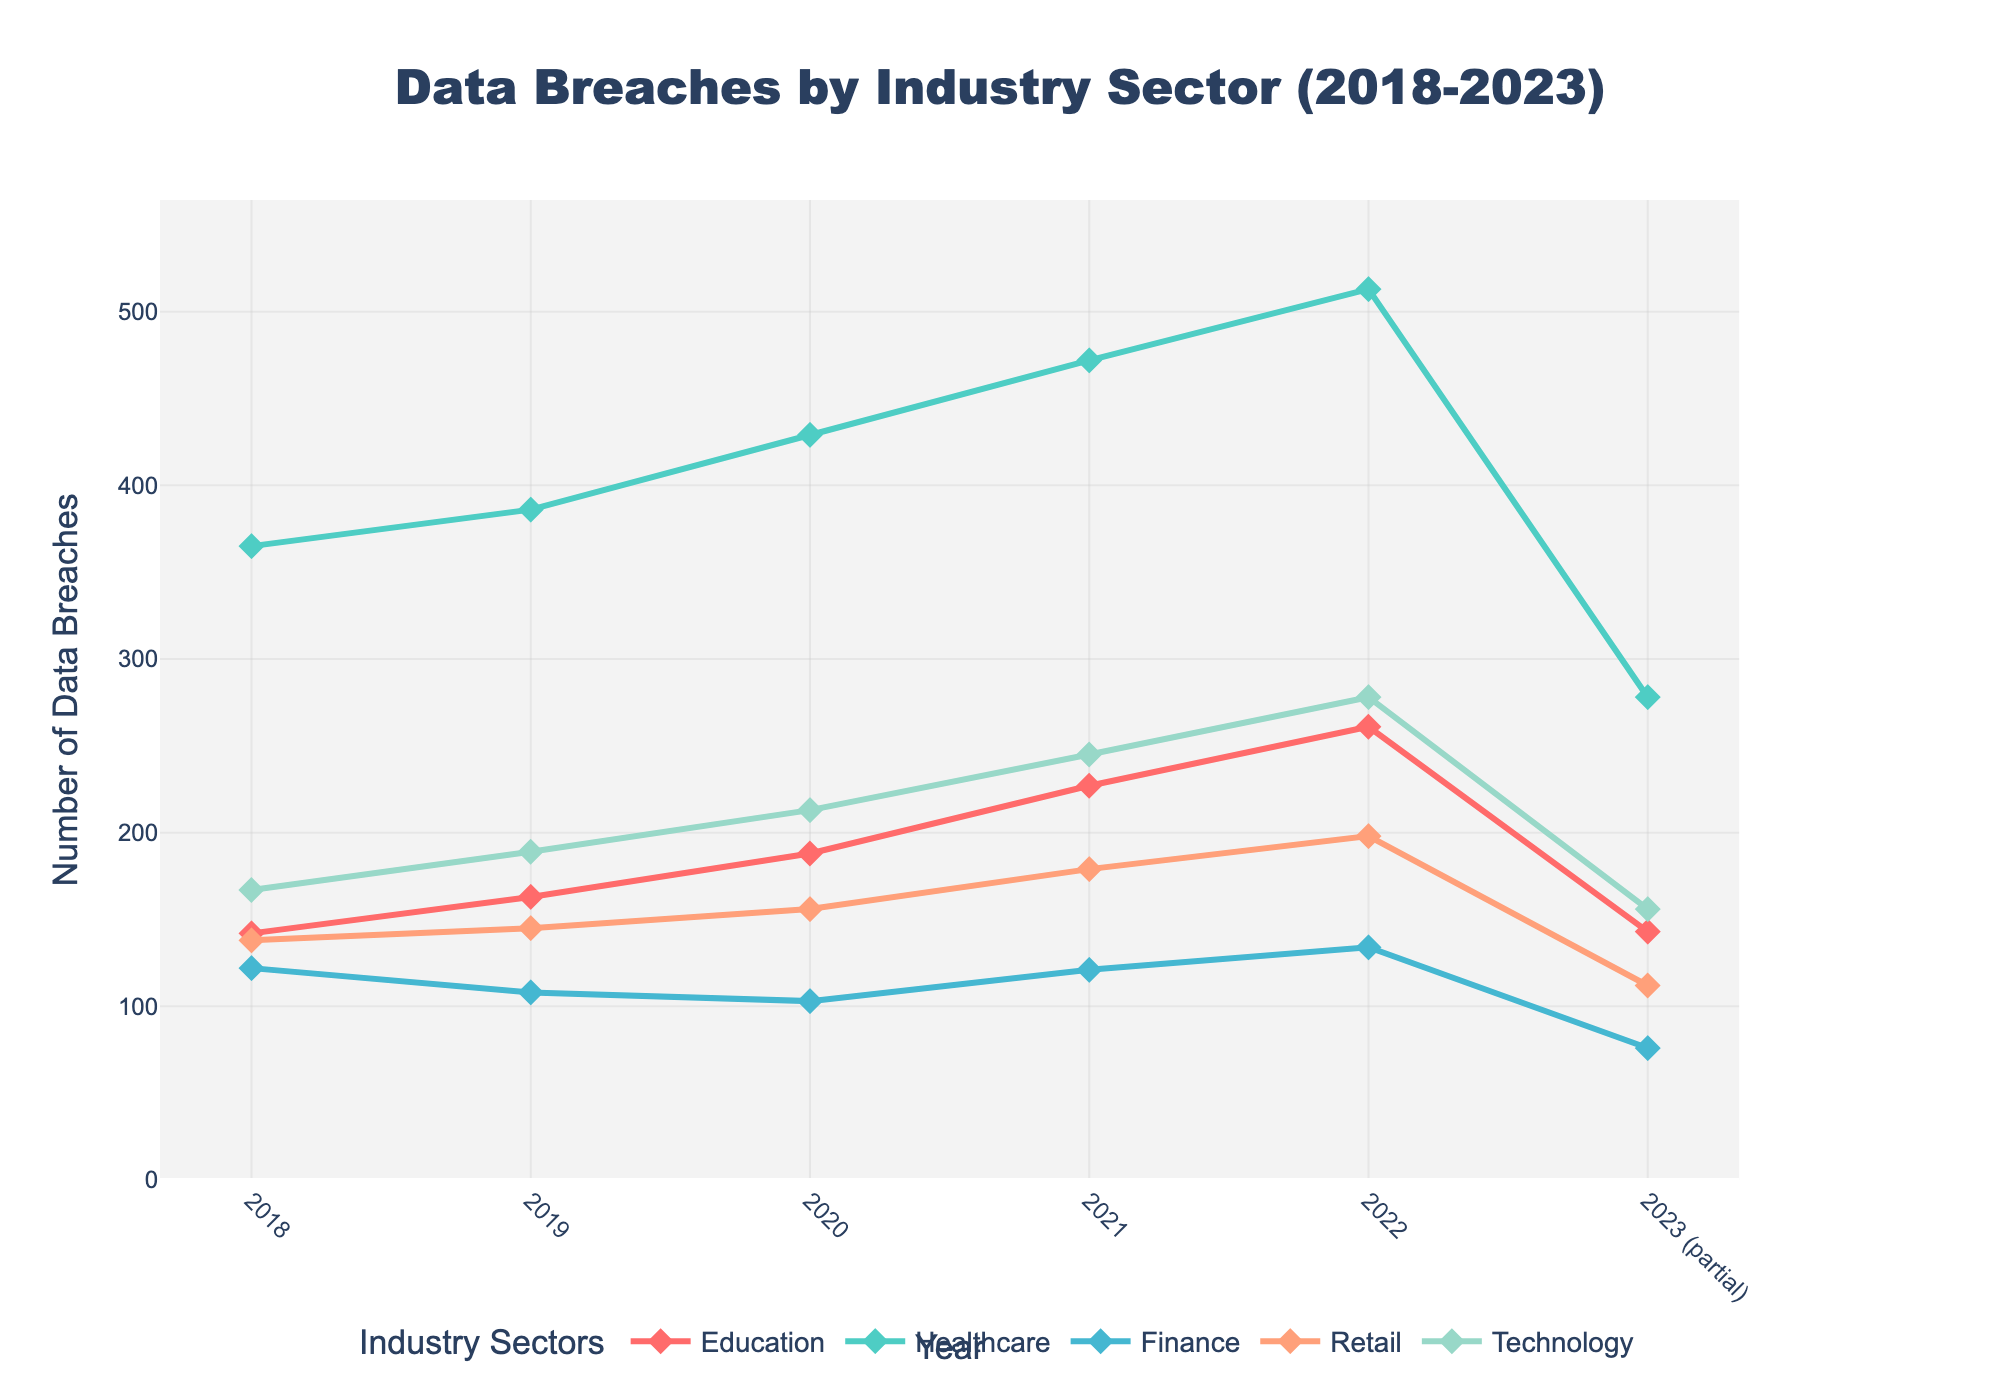Which year experienced the highest number of data breaches in educational institutions? Looking at the line for educational institutions, we identify the peak point. The highest value on this line appears in 2022 with 261 breaches.
Answer: 2022 How does the number of data breaches in educational institutions in 2020 compare to that in the finance sector for the same year? For 2020, the number of data breaches in educational institutions is 188, whereas the finance sector experienced 103 breaches. Therefore, educational institutions had 85 more breaches than the finance sector.
Answer: 85 more Between 2018 and 2022, which year saw the largest increase in data breaches for educational institutions? By examining the difference between each consecutive year's data breaches for educational institutions, we find that the largest increase occurred from 2021 (227 breaches) to 2022 (261 breaches), a difference of 34.
Answer: From 2021 to 2022 What is the overall trend in the number of data breaches in educational institutions over the years shown? The trend line for educational institutions shows a consistent increase from 142 breaches in 2018 to 261 in 2022, indicating a rising trend.
Answer: Increasing Compared to 2021, did the year 2022 see more or fewer data breaches in the healthcare sector? By how many? In 2021, the healthcare sector had 472 breaches, and in 2022 it had 513. Comparing these numbers shows that there were 41 more breaches in 2022.
Answer: 41 more What is the average number of data breaches in educational institutions from 2018 to 2022? First, sum the numbers for each year (142 + 163 + 188 + 227 + 261 = 981). Then, divide by the number of years (5) to get the average: 981 / 5 = 196.2.
Answer: 196.2 By how much did the number of data breaches in educational institutions change from 2019 to 2020? In 2019, there were 163 breaches, and in 2020 there were 188. The change is 188 - 163 = 25.
Answer: 25 Which industry sector had the least number of data breaches in 2023? Look at the value for each sector in 2023; the finance sector has the least with 76 breaches.
Answer: Finance What is the color representing educational institutions in the chart? The educational institutions' line can be identified by the unique red color on the graph.
Answer: Red How does the number of data breaches in educational institutions in 2023 so far compare to 2021? Comparing the partial data for 2023 (143 breaches) with 2021 (227 breaches) reveals that 2023 so far has 84 fewer breaches.
Answer: 84 fewer 